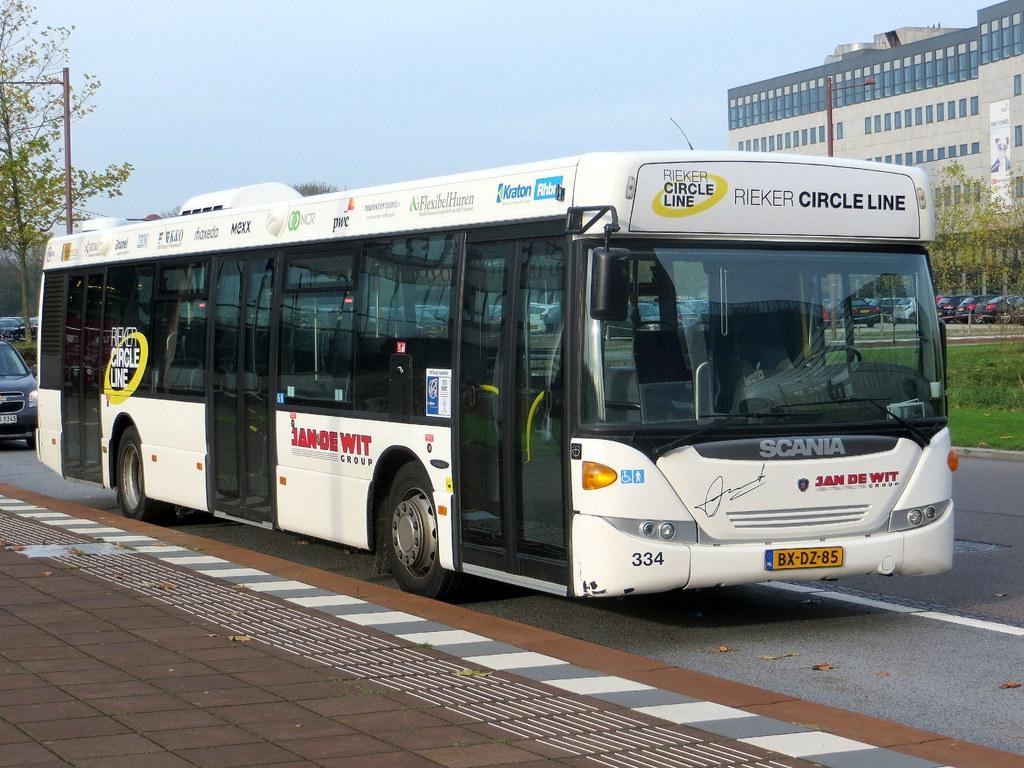<image>
Offer a succinct explanation of the picture presented. A Rieker Circle Line bus sits on the side of the road. 